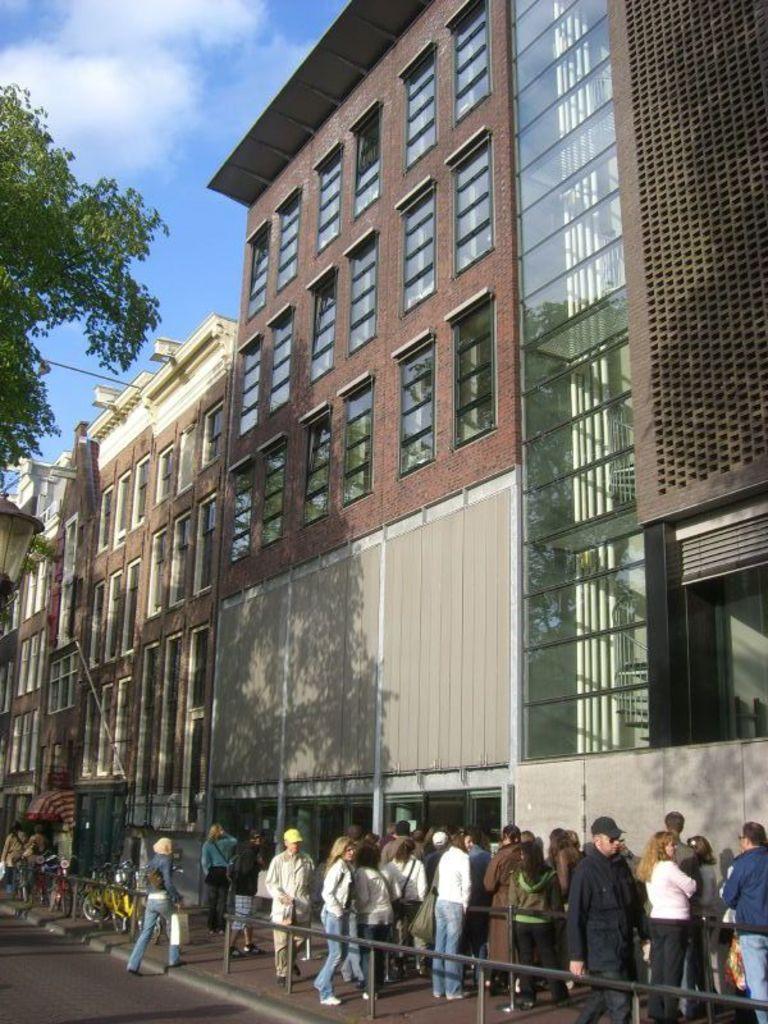How would you summarize this image in a sentence or two? In the picture I can see fence, a tree, people standing on the ground, bicycles and some other things. In the background I can see the sky. 